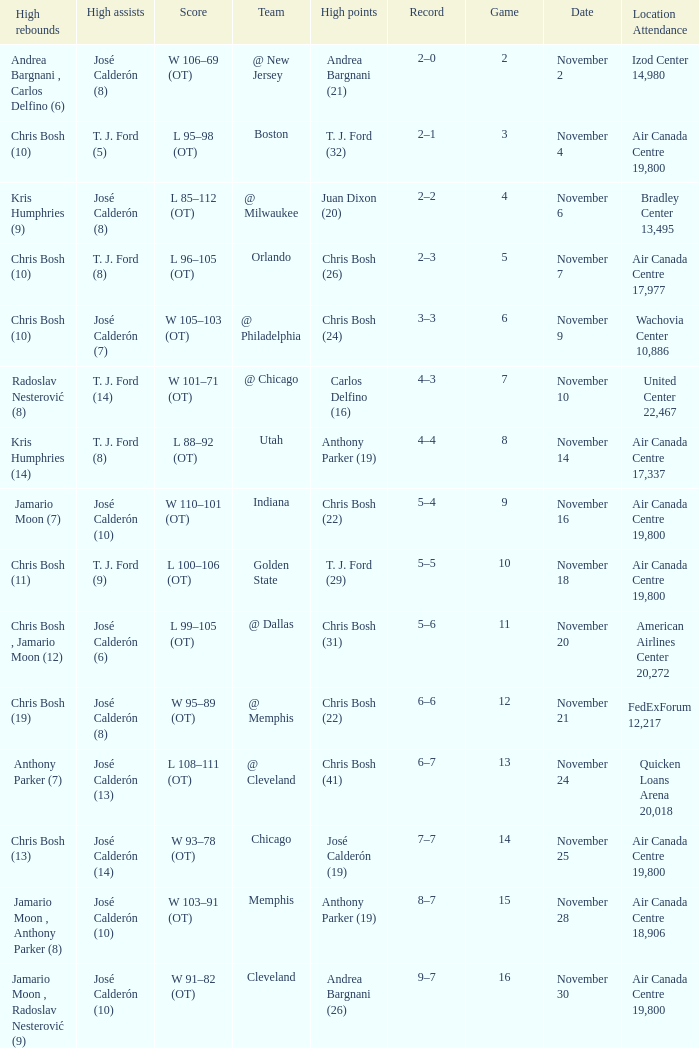What is the score when the team is @ cleveland? L 108–111 (OT). 